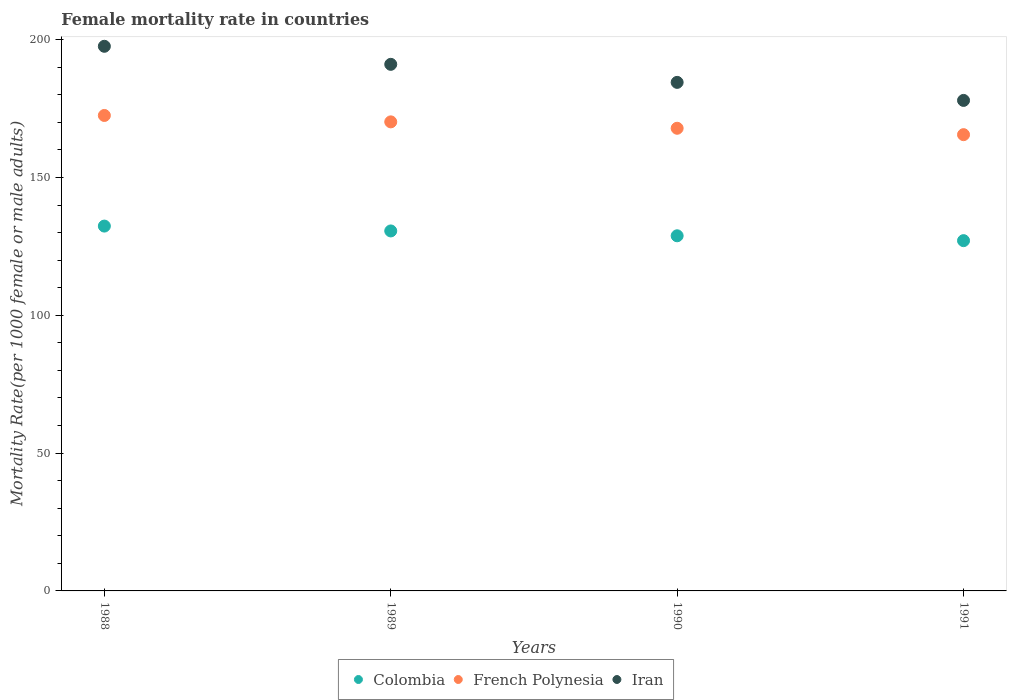Is the number of dotlines equal to the number of legend labels?
Your answer should be very brief. Yes. What is the female mortality rate in Iran in 1991?
Keep it short and to the point. 177.94. Across all years, what is the maximum female mortality rate in Iran?
Provide a succinct answer. 197.58. Across all years, what is the minimum female mortality rate in French Polynesia?
Keep it short and to the point. 165.52. What is the total female mortality rate in French Polynesia in the graph?
Make the answer very short. 676.01. What is the difference between the female mortality rate in Iran in 1990 and that in 1991?
Your answer should be very brief. 6.55. What is the difference between the female mortality rate in Colombia in 1991 and the female mortality rate in Iran in 1989?
Your answer should be compact. -63.96. What is the average female mortality rate in Colombia per year?
Give a very brief answer. 129.71. In the year 1989, what is the difference between the female mortality rate in Colombia and female mortality rate in French Polynesia?
Ensure brevity in your answer.  -39.57. In how many years, is the female mortality rate in Colombia greater than 120?
Your answer should be very brief. 4. What is the ratio of the female mortality rate in Iran in 1988 to that in 1991?
Your answer should be compact. 1.11. Is the difference between the female mortality rate in Colombia in 1989 and 1991 greater than the difference between the female mortality rate in French Polynesia in 1989 and 1991?
Ensure brevity in your answer.  No. What is the difference between the highest and the second highest female mortality rate in French Polynesia?
Your answer should be compact. 2.32. What is the difference between the highest and the lowest female mortality rate in French Polynesia?
Ensure brevity in your answer.  6.97. Is the sum of the female mortality rate in Colombia in 1990 and 1991 greater than the maximum female mortality rate in French Polynesia across all years?
Offer a very short reply. Yes. Is it the case that in every year, the sum of the female mortality rate in French Polynesia and female mortality rate in Iran  is greater than the female mortality rate in Colombia?
Your answer should be very brief. Yes. Is the female mortality rate in Iran strictly greater than the female mortality rate in Colombia over the years?
Provide a short and direct response. Yes. How many dotlines are there?
Give a very brief answer. 3. How many years are there in the graph?
Your answer should be very brief. 4. What is the difference between two consecutive major ticks on the Y-axis?
Provide a succinct answer. 50. How many legend labels are there?
Keep it short and to the point. 3. What is the title of the graph?
Your answer should be compact. Female mortality rate in countries. Does "Israel" appear as one of the legend labels in the graph?
Provide a succinct answer. No. What is the label or title of the Y-axis?
Give a very brief answer. Mortality Rate(per 1000 female or male adults). What is the Mortality Rate(per 1000 female or male adults) of Colombia in 1988?
Offer a very short reply. 132.36. What is the Mortality Rate(per 1000 female or male adults) in French Polynesia in 1988?
Ensure brevity in your answer.  172.49. What is the Mortality Rate(per 1000 female or male adults) in Iran in 1988?
Keep it short and to the point. 197.58. What is the Mortality Rate(per 1000 female or male adults) in Colombia in 1989?
Offer a very short reply. 130.59. What is the Mortality Rate(per 1000 female or male adults) of French Polynesia in 1989?
Provide a succinct answer. 170.16. What is the Mortality Rate(per 1000 female or male adults) of Iran in 1989?
Offer a very short reply. 191.03. What is the Mortality Rate(per 1000 female or male adults) of Colombia in 1990?
Offer a terse response. 128.83. What is the Mortality Rate(per 1000 female or male adults) in French Polynesia in 1990?
Offer a very short reply. 167.84. What is the Mortality Rate(per 1000 female or male adults) of Iran in 1990?
Provide a succinct answer. 184.49. What is the Mortality Rate(per 1000 female or male adults) of Colombia in 1991?
Offer a terse response. 127.07. What is the Mortality Rate(per 1000 female or male adults) of French Polynesia in 1991?
Provide a short and direct response. 165.52. What is the Mortality Rate(per 1000 female or male adults) in Iran in 1991?
Your answer should be compact. 177.94. Across all years, what is the maximum Mortality Rate(per 1000 female or male adults) in Colombia?
Your answer should be very brief. 132.36. Across all years, what is the maximum Mortality Rate(per 1000 female or male adults) of French Polynesia?
Provide a short and direct response. 172.49. Across all years, what is the maximum Mortality Rate(per 1000 female or male adults) in Iran?
Provide a short and direct response. 197.58. Across all years, what is the minimum Mortality Rate(per 1000 female or male adults) of Colombia?
Provide a short and direct response. 127.07. Across all years, what is the minimum Mortality Rate(per 1000 female or male adults) of French Polynesia?
Offer a very short reply. 165.52. Across all years, what is the minimum Mortality Rate(per 1000 female or male adults) of Iran?
Give a very brief answer. 177.94. What is the total Mortality Rate(per 1000 female or male adults) of Colombia in the graph?
Make the answer very short. 518.86. What is the total Mortality Rate(per 1000 female or male adults) in French Polynesia in the graph?
Ensure brevity in your answer.  676.01. What is the total Mortality Rate(per 1000 female or male adults) of Iran in the graph?
Give a very brief answer. 751.05. What is the difference between the Mortality Rate(per 1000 female or male adults) of Colombia in 1988 and that in 1989?
Provide a short and direct response. 1.76. What is the difference between the Mortality Rate(per 1000 female or male adults) of French Polynesia in 1988 and that in 1989?
Offer a terse response. 2.32. What is the difference between the Mortality Rate(per 1000 female or male adults) in Iran in 1988 and that in 1989?
Provide a succinct answer. 6.54. What is the difference between the Mortality Rate(per 1000 female or male adults) of Colombia in 1988 and that in 1990?
Keep it short and to the point. 3.52. What is the difference between the Mortality Rate(per 1000 female or male adults) in French Polynesia in 1988 and that in 1990?
Your response must be concise. 4.64. What is the difference between the Mortality Rate(per 1000 female or male adults) of Iran in 1988 and that in 1990?
Provide a short and direct response. 13.09. What is the difference between the Mortality Rate(per 1000 female or male adults) of Colombia in 1988 and that in 1991?
Ensure brevity in your answer.  5.28. What is the difference between the Mortality Rate(per 1000 female or male adults) in French Polynesia in 1988 and that in 1991?
Offer a very short reply. 6.96. What is the difference between the Mortality Rate(per 1000 female or male adults) in Iran in 1988 and that in 1991?
Keep it short and to the point. 19.64. What is the difference between the Mortality Rate(per 1000 female or male adults) of Colombia in 1989 and that in 1990?
Offer a terse response. 1.76. What is the difference between the Mortality Rate(per 1000 female or male adults) in French Polynesia in 1989 and that in 1990?
Your response must be concise. 2.32. What is the difference between the Mortality Rate(per 1000 female or male adults) in Iran in 1989 and that in 1990?
Your answer should be compact. 6.54. What is the difference between the Mortality Rate(per 1000 female or male adults) in Colombia in 1989 and that in 1991?
Your answer should be compact. 3.52. What is the difference between the Mortality Rate(per 1000 female or male adults) of French Polynesia in 1989 and that in 1991?
Offer a terse response. 4.64. What is the difference between the Mortality Rate(per 1000 female or male adults) of Iran in 1989 and that in 1991?
Give a very brief answer. 13.09. What is the difference between the Mortality Rate(per 1000 female or male adults) in Colombia in 1990 and that in 1991?
Provide a short and direct response. 1.76. What is the difference between the Mortality Rate(per 1000 female or male adults) in French Polynesia in 1990 and that in 1991?
Provide a short and direct response. 2.32. What is the difference between the Mortality Rate(per 1000 female or male adults) of Iran in 1990 and that in 1991?
Keep it short and to the point. 6.54. What is the difference between the Mortality Rate(per 1000 female or male adults) in Colombia in 1988 and the Mortality Rate(per 1000 female or male adults) in French Polynesia in 1989?
Your answer should be compact. -37.81. What is the difference between the Mortality Rate(per 1000 female or male adults) of Colombia in 1988 and the Mortality Rate(per 1000 female or male adults) of Iran in 1989?
Make the answer very short. -58.68. What is the difference between the Mortality Rate(per 1000 female or male adults) of French Polynesia in 1988 and the Mortality Rate(per 1000 female or male adults) of Iran in 1989?
Your response must be concise. -18.55. What is the difference between the Mortality Rate(per 1000 female or male adults) of Colombia in 1988 and the Mortality Rate(per 1000 female or male adults) of French Polynesia in 1990?
Give a very brief answer. -35.48. What is the difference between the Mortality Rate(per 1000 female or male adults) in Colombia in 1988 and the Mortality Rate(per 1000 female or male adults) in Iran in 1990?
Provide a short and direct response. -52.13. What is the difference between the Mortality Rate(per 1000 female or male adults) in French Polynesia in 1988 and the Mortality Rate(per 1000 female or male adults) in Iran in 1990?
Provide a succinct answer. -12.01. What is the difference between the Mortality Rate(per 1000 female or male adults) in Colombia in 1988 and the Mortality Rate(per 1000 female or male adults) in French Polynesia in 1991?
Your response must be concise. -33.16. What is the difference between the Mortality Rate(per 1000 female or male adults) of Colombia in 1988 and the Mortality Rate(per 1000 female or male adults) of Iran in 1991?
Keep it short and to the point. -45.59. What is the difference between the Mortality Rate(per 1000 female or male adults) of French Polynesia in 1988 and the Mortality Rate(per 1000 female or male adults) of Iran in 1991?
Your answer should be compact. -5.46. What is the difference between the Mortality Rate(per 1000 female or male adults) of Colombia in 1989 and the Mortality Rate(per 1000 female or male adults) of French Polynesia in 1990?
Provide a succinct answer. -37.25. What is the difference between the Mortality Rate(per 1000 female or male adults) in Colombia in 1989 and the Mortality Rate(per 1000 female or male adults) in Iran in 1990?
Provide a short and direct response. -53.9. What is the difference between the Mortality Rate(per 1000 female or male adults) of French Polynesia in 1989 and the Mortality Rate(per 1000 female or male adults) of Iran in 1990?
Make the answer very short. -14.33. What is the difference between the Mortality Rate(per 1000 female or male adults) of Colombia in 1989 and the Mortality Rate(per 1000 female or male adults) of French Polynesia in 1991?
Provide a short and direct response. -34.93. What is the difference between the Mortality Rate(per 1000 female or male adults) of Colombia in 1989 and the Mortality Rate(per 1000 female or male adults) of Iran in 1991?
Offer a very short reply. -47.35. What is the difference between the Mortality Rate(per 1000 female or male adults) in French Polynesia in 1989 and the Mortality Rate(per 1000 female or male adults) in Iran in 1991?
Your answer should be very brief. -7.78. What is the difference between the Mortality Rate(per 1000 female or male adults) in Colombia in 1990 and the Mortality Rate(per 1000 female or male adults) in French Polynesia in 1991?
Give a very brief answer. -36.69. What is the difference between the Mortality Rate(per 1000 female or male adults) of Colombia in 1990 and the Mortality Rate(per 1000 female or male adults) of Iran in 1991?
Provide a succinct answer. -49.11. What is the difference between the Mortality Rate(per 1000 female or male adults) in French Polynesia in 1990 and the Mortality Rate(per 1000 female or male adults) in Iran in 1991?
Offer a terse response. -10.1. What is the average Mortality Rate(per 1000 female or male adults) in Colombia per year?
Offer a very short reply. 129.71. What is the average Mortality Rate(per 1000 female or male adults) in French Polynesia per year?
Your answer should be compact. 169. What is the average Mortality Rate(per 1000 female or male adults) of Iran per year?
Provide a succinct answer. 187.76. In the year 1988, what is the difference between the Mortality Rate(per 1000 female or male adults) of Colombia and Mortality Rate(per 1000 female or male adults) of French Polynesia?
Offer a very short reply. -40.13. In the year 1988, what is the difference between the Mortality Rate(per 1000 female or male adults) in Colombia and Mortality Rate(per 1000 female or male adults) in Iran?
Provide a short and direct response. -65.22. In the year 1988, what is the difference between the Mortality Rate(per 1000 female or male adults) in French Polynesia and Mortality Rate(per 1000 female or male adults) in Iran?
Your answer should be very brief. -25.09. In the year 1989, what is the difference between the Mortality Rate(per 1000 female or male adults) in Colombia and Mortality Rate(per 1000 female or male adults) in French Polynesia?
Provide a short and direct response. -39.57. In the year 1989, what is the difference between the Mortality Rate(per 1000 female or male adults) in Colombia and Mortality Rate(per 1000 female or male adults) in Iran?
Your answer should be very brief. -60.44. In the year 1989, what is the difference between the Mortality Rate(per 1000 female or male adults) of French Polynesia and Mortality Rate(per 1000 female or male adults) of Iran?
Your answer should be very brief. -20.87. In the year 1990, what is the difference between the Mortality Rate(per 1000 female or male adults) of Colombia and Mortality Rate(per 1000 female or male adults) of French Polynesia?
Offer a very short reply. -39.01. In the year 1990, what is the difference between the Mortality Rate(per 1000 female or male adults) of Colombia and Mortality Rate(per 1000 female or male adults) of Iran?
Offer a very short reply. -55.66. In the year 1990, what is the difference between the Mortality Rate(per 1000 female or male adults) in French Polynesia and Mortality Rate(per 1000 female or male adults) in Iran?
Offer a terse response. -16.65. In the year 1991, what is the difference between the Mortality Rate(per 1000 female or male adults) of Colombia and Mortality Rate(per 1000 female or male adults) of French Polynesia?
Your answer should be very brief. -38.45. In the year 1991, what is the difference between the Mortality Rate(per 1000 female or male adults) in Colombia and Mortality Rate(per 1000 female or male adults) in Iran?
Keep it short and to the point. -50.87. In the year 1991, what is the difference between the Mortality Rate(per 1000 female or male adults) of French Polynesia and Mortality Rate(per 1000 female or male adults) of Iran?
Offer a terse response. -12.43. What is the ratio of the Mortality Rate(per 1000 female or male adults) in Colombia in 1988 to that in 1989?
Provide a succinct answer. 1.01. What is the ratio of the Mortality Rate(per 1000 female or male adults) in French Polynesia in 1988 to that in 1989?
Provide a succinct answer. 1.01. What is the ratio of the Mortality Rate(per 1000 female or male adults) in Iran in 1988 to that in 1989?
Make the answer very short. 1.03. What is the ratio of the Mortality Rate(per 1000 female or male adults) in Colombia in 1988 to that in 1990?
Offer a very short reply. 1.03. What is the ratio of the Mortality Rate(per 1000 female or male adults) of French Polynesia in 1988 to that in 1990?
Provide a short and direct response. 1.03. What is the ratio of the Mortality Rate(per 1000 female or male adults) of Iran in 1988 to that in 1990?
Your answer should be compact. 1.07. What is the ratio of the Mortality Rate(per 1000 female or male adults) in Colombia in 1988 to that in 1991?
Keep it short and to the point. 1.04. What is the ratio of the Mortality Rate(per 1000 female or male adults) in French Polynesia in 1988 to that in 1991?
Offer a terse response. 1.04. What is the ratio of the Mortality Rate(per 1000 female or male adults) in Iran in 1988 to that in 1991?
Your response must be concise. 1.11. What is the ratio of the Mortality Rate(per 1000 female or male adults) of Colombia in 1989 to that in 1990?
Keep it short and to the point. 1.01. What is the ratio of the Mortality Rate(per 1000 female or male adults) of French Polynesia in 1989 to that in 1990?
Make the answer very short. 1.01. What is the ratio of the Mortality Rate(per 1000 female or male adults) in Iran in 1989 to that in 1990?
Offer a terse response. 1.04. What is the ratio of the Mortality Rate(per 1000 female or male adults) of Colombia in 1989 to that in 1991?
Your answer should be compact. 1.03. What is the ratio of the Mortality Rate(per 1000 female or male adults) of French Polynesia in 1989 to that in 1991?
Keep it short and to the point. 1.03. What is the ratio of the Mortality Rate(per 1000 female or male adults) of Iran in 1989 to that in 1991?
Keep it short and to the point. 1.07. What is the ratio of the Mortality Rate(per 1000 female or male adults) in Colombia in 1990 to that in 1991?
Ensure brevity in your answer.  1.01. What is the ratio of the Mortality Rate(per 1000 female or male adults) of Iran in 1990 to that in 1991?
Provide a short and direct response. 1.04. What is the difference between the highest and the second highest Mortality Rate(per 1000 female or male adults) of Colombia?
Ensure brevity in your answer.  1.76. What is the difference between the highest and the second highest Mortality Rate(per 1000 female or male adults) of French Polynesia?
Offer a terse response. 2.32. What is the difference between the highest and the second highest Mortality Rate(per 1000 female or male adults) of Iran?
Offer a very short reply. 6.54. What is the difference between the highest and the lowest Mortality Rate(per 1000 female or male adults) in Colombia?
Your answer should be very brief. 5.28. What is the difference between the highest and the lowest Mortality Rate(per 1000 female or male adults) of French Polynesia?
Provide a succinct answer. 6.96. What is the difference between the highest and the lowest Mortality Rate(per 1000 female or male adults) in Iran?
Make the answer very short. 19.64. 